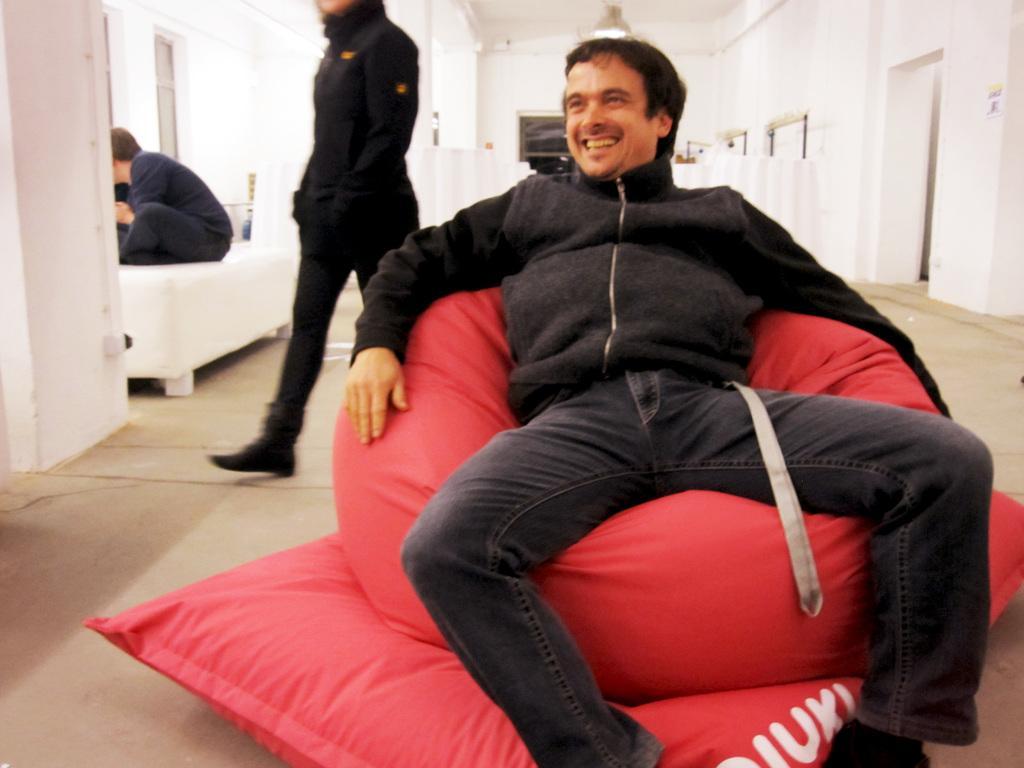In one or two sentences, can you explain what this image depicts? In this image there is a person with a smile on his face is sitting on a bean bag, behind the person there is another person walking, in the background of the image there is another person sitting on a sofa chair. 